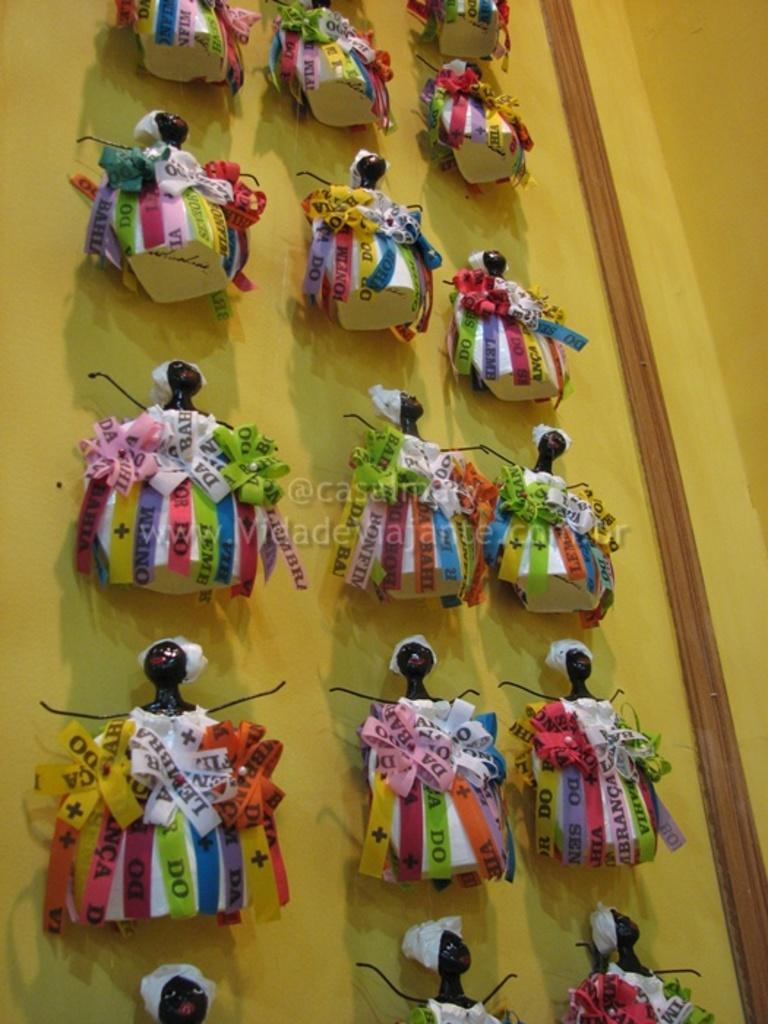What type of objects are in the image? There are toy shapes in the image. Where are the toy shapes located? The toy shapes are attached to a wall. What color is the wall that the toy shapes are attached to? The wall is yellow in color. Reasoning: Let's think step by following the guidelines to produce the conversation. We start by identifying the main subject in the image, which are the toy shapes. Then, we describe their location and the color of the wall they are attached to. Each question is designed to elicit a specific detail about the image that is known from the provided facts. Absurd Question/Answer: What type of growth can be seen on the wall in the image? There is no growth visible on the wall in the image; it is a yellow wall with toy shapes attached to it. 